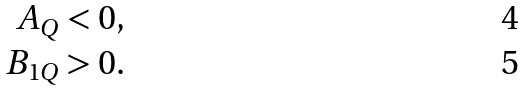Convert formula to latex. <formula><loc_0><loc_0><loc_500><loc_500>A _ { Q } & < 0 , \\ B _ { 1 Q } & > 0 .</formula> 